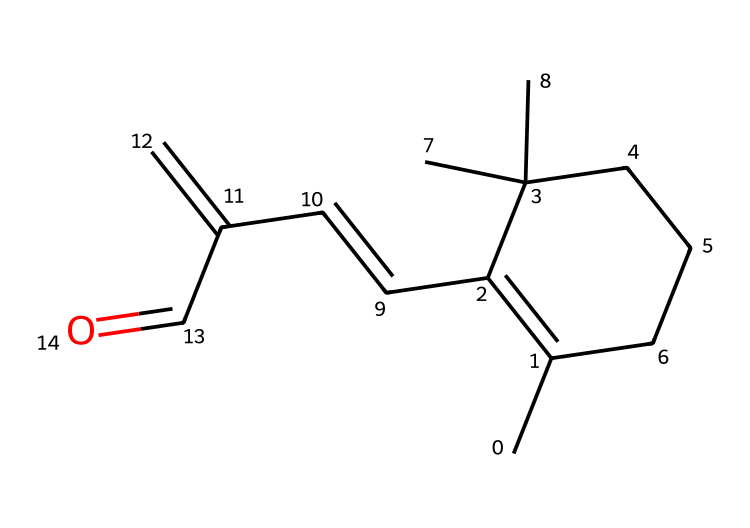What is the chemical name of this structure? This structure corresponds to retinal, which is a form of vitamin A involved in vision. The presence of a conjugated system and an aldehyde functional group indicates its identity.
Answer: retinal How many carbon atoms are in this molecule? To determine the number of carbon atoms, we count each carbon in the SMILES representation. The molecule contains a total of 15 carbon atoms, which can be directly tallied from the structure.
Answer: 15 What type of functional group is present in this compound? The compound has an aldehyde functional group, recognizable by the carbonyl (C=O) at the end of a carbon chain. This type of group defines it as an aldehyde.
Answer: aldehyde How many double bonds does this molecule have? By analyzing the connections in the SMILES, we can identify 4 double bonds in total as they are between various carbon atoms and the carbonyl group.
Answer: 4 Why is retinal important for vision? Retinal is crucial for vision because it plays a significant role in the visual cycle by absorbing light and changing its configuration, which is necessary for phototransduction in the retina. This explains why it is essential for sight.
Answer: vital for phototransduction Does this compound belong to the class of aromatic compounds? This compound is not classified as aromatic despite having double bonds; while it has a conjugated system, it lacks the specific structure and stability features characteristic of aromatic compounds like benzene.
Answer: no What is the degree of saturation of this molecule? The degree of saturation in an organic compound can be calculated based on the number of hydrogen atoms relative to the number of carbon atoms. Given the structure and the presence of double bonds, this compound has a degree of saturation of 8.
Answer: 8 